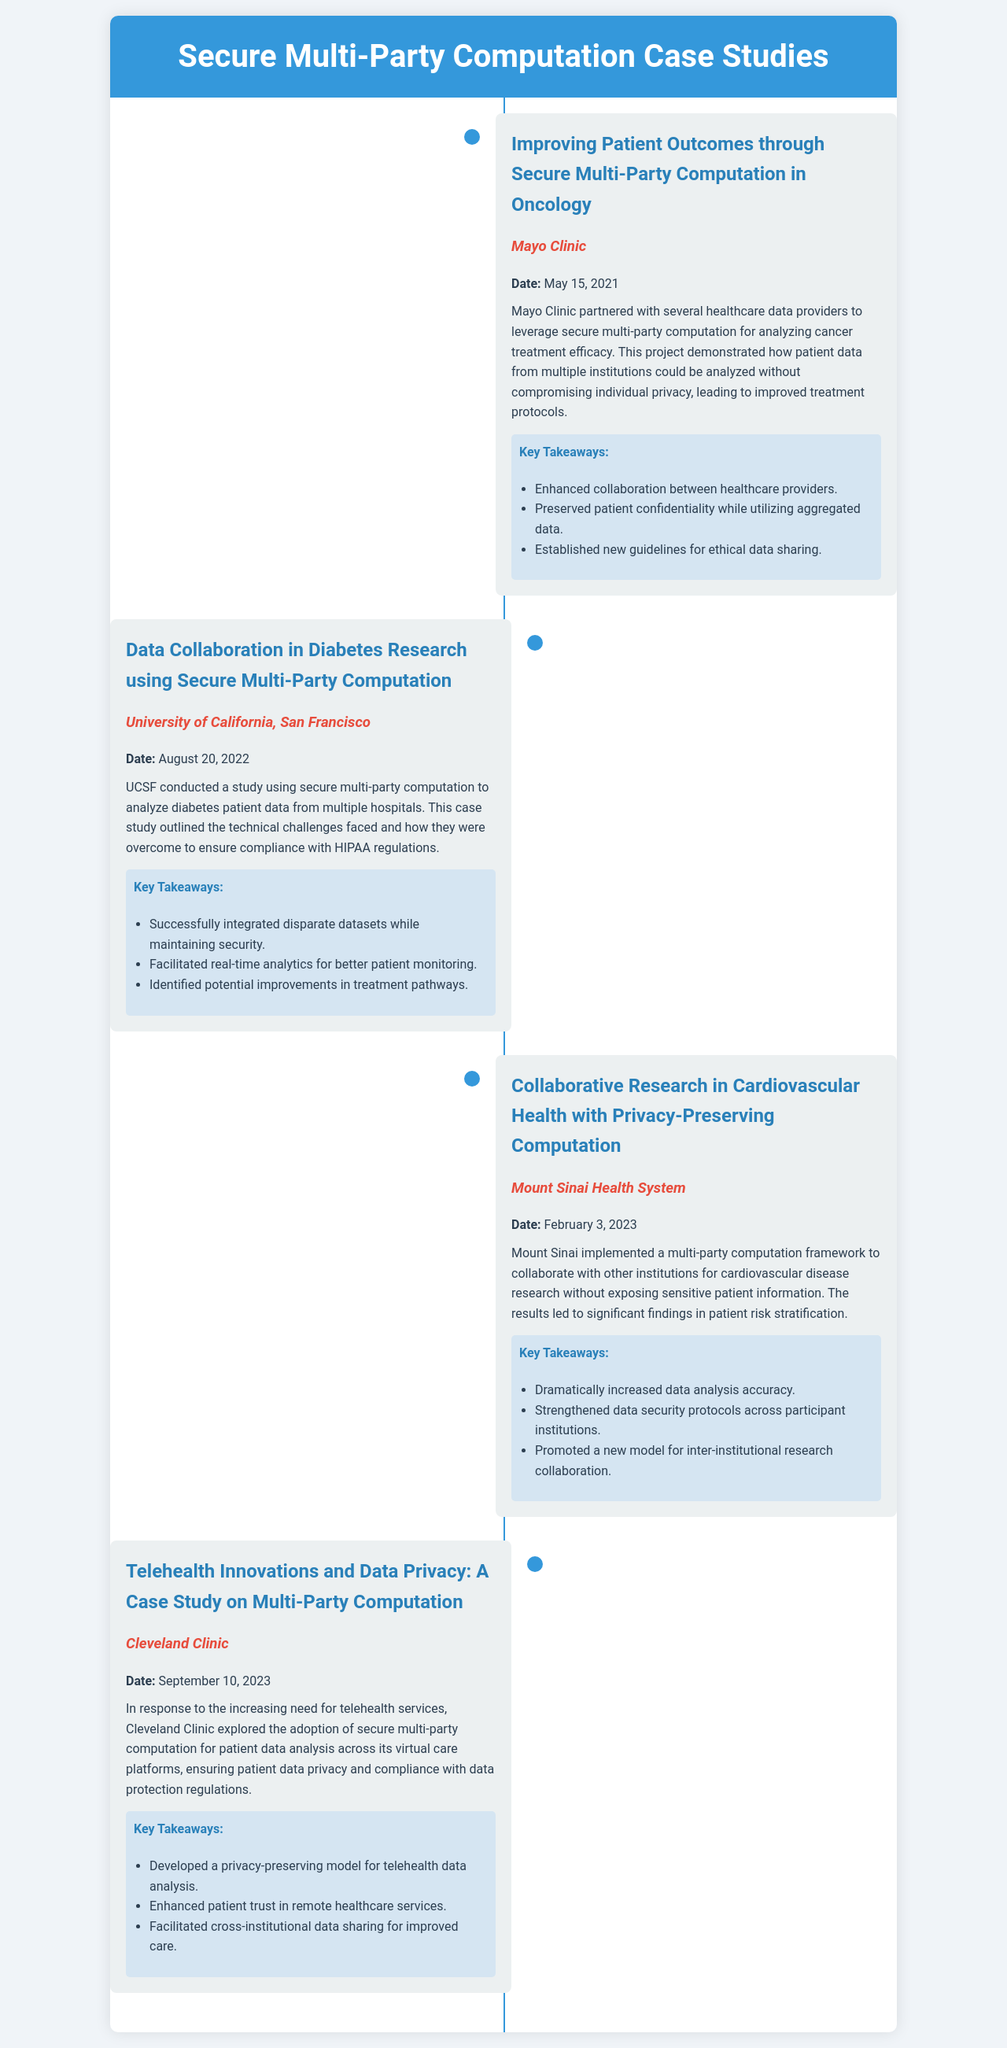What is the title of the first case study? The title of the first case study is "Improving Patient Outcomes through Secure Multi-Party Computation in Oncology."
Answer: Improving Patient Outcomes through Secure Multi-Party Computation in Oncology Who conducted the second case study? The second case study was conducted by the University of California, San Francisco.
Answer: University of California, San Francisco What date was the fourth case study presented? The fourth case study was presented on September 10, 2023.
Answer: September 10, 2023 What was a key takeaway from the case study by Mount Sinai Health System? A key takeaway from the Mount Sinai Health System case study was "Dramatically increased data analysis accuracy."
Answer: Dramatically increased data analysis accuracy What technology was implemented by Cleveland Clinic for data analysis? Cleveland Clinic implemented secure multi-party computation for data analysis.
Answer: secure multi-party computation Which institution collaborated on diabetes research? University of California, San Francisco collaborated on diabetes research.
Answer: University of California, San Francisco What was the main focus of the Mayo Clinic's case study? The main focus of the Mayo Clinic's case study was on analyzing cancer treatment efficacy.
Answer: analyzing cancer treatment efficacy How many key takeaways are listed for the case study by Mount Sinai? There are three key takeaways listed for the Mount Sinai case study.
Answer: three What was promoted as a new model in the Mount Sinai case study? A new model for inter-institutional research collaboration was promoted.
Answer: inter-institutional research collaboration 